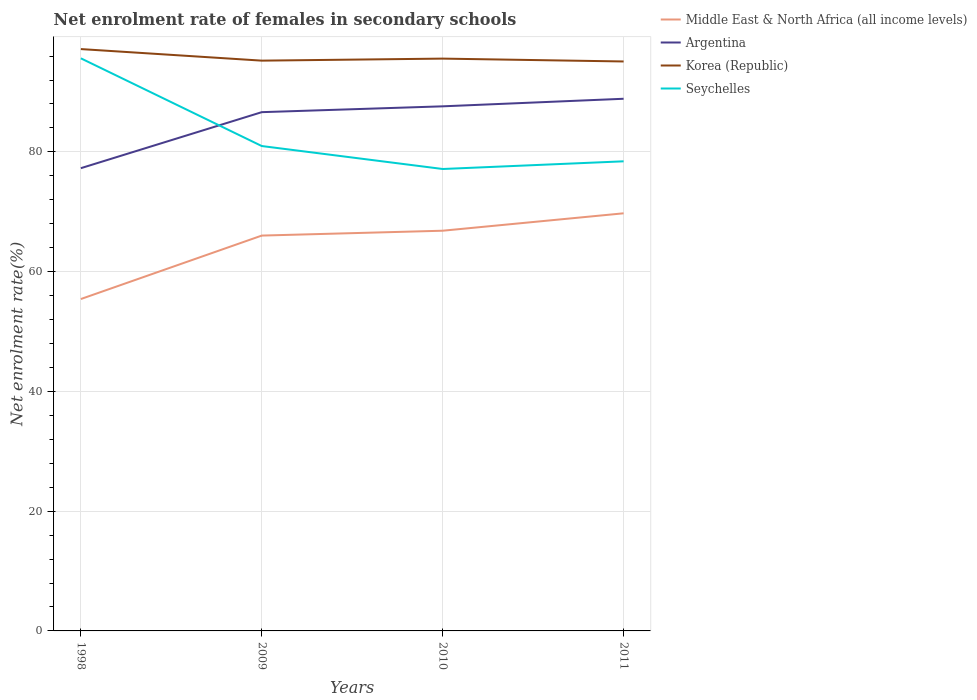Across all years, what is the maximum net enrolment rate of females in secondary schools in Seychelles?
Make the answer very short. 77.14. In which year was the net enrolment rate of females in secondary schools in Korea (Republic) maximum?
Make the answer very short. 2011. What is the total net enrolment rate of females in secondary schools in Korea (Republic) in the graph?
Give a very brief answer. 1.59. What is the difference between the highest and the second highest net enrolment rate of females in secondary schools in Argentina?
Provide a succinct answer. 11.59. What is the difference between the highest and the lowest net enrolment rate of females in secondary schools in Argentina?
Ensure brevity in your answer.  3. What is the difference between two consecutive major ticks on the Y-axis?
Make the answer very short. 20. Are the values on the major ticks of Y-axis written in scientific E-notation?
Keep it short and to the point. No. How are the legend labels stacked?
Your response must be concise. Vertical. What is the title of the graph?
Provide a short and direct response. Net enrolment rate of females in secondary schools. What is the label or title of the X-axis?
Ensure brevity in your answer.  Years. What is the label or title of the Y-axis?
Ensure brevity in your answer.  Net enrolment rate(%). What is the Net enrolment rate(%) in Middle East & North Africa (all income levels) in 1998?
Ensure brevity in your answer.  55.43. What is the Net enrolment rate(%) of Argentina in 1998?
Make the answer very short. 77.28. What is the Net enrolment rate(%) of Korea (Republic) in 1998?
Your response must be concise. 97.17. What is the Net enrolment rate(%) of Seychelles in 1998?
Offer a terse response. 95.63. What is the Net enrolment rate(%) in Middle East & North Africa (all income levels) in 2009?
Ensure brevity in your answer.  66.02. What is the Net enrolment rate(%) of Argentina in 2009?
Provide a short and direct response. 86.64. What is the Net enrolment rate(%) in Korea (Republic) in 2009?
Make the answer very short. 95.24. What is the Net enrolment rate(%) of Seychelles in 2009?
Provide a succinct answer. 80.98. What is the Net enrolment rate(%) in Middle East & North Africa (all income levels) in 2010?
Your response must be concise. 66.84. What is the Net enrolment rate(%) of Argentina in 2010?
Provide a short and direct response. 87.61. What is the Net enrolment rate(%) in Korea (Republic) in 2010?
Your answer should be compact. 95.58. What is the Net enrolment rate(%) in Seychelles in 2010?
Provide a succinct answer. 77.14. What is the Net enrolment rate(%) in Middle East & North Africa (all income levels) in 2011?
Your answer should be compact. 69.74. What is the Net enrolment rate(%) of Argentina in 2011?
Keep it short and to the point. 88.87. What is the Net enrolment rate(%) in Korea (Republic) in 2011?
Your answer should be compact. 95.1. What is the Net enrolment rate(%) of Seychelles in 2011?
Your response must be concise. 78.43. Across all years, what is the maximum Net enrolment rate(%) of Middle East & North Africa (all income levels)?
Your response must be concise. 69.74. Across all years, what is the maximum Net enrolment rate(%) in Argentina?
Provide a short and direct response. 88.87. Across all years, what is the maximum Net enrolment rate(%) in Korea (Republic)?
Your answer should be very brief. 97.17. Across all years, what is the maximum Net enrolment rate(%) in Seychelles?
Ensure brevity in your answer.  95.63. Across all years, what is the minimum Net enrolment rate(%) in Middle East & North Africa (all income levels)?
Keep it short and to the point. 55.43. Across all years, what is the minimum Net enrolment rate(%) in Argentina?
Offer a very short reply. 77.28. Across all years, what is the minimum Net enrolment rate(%) in Korea (Republic)?
Keep it short and to the point. 95.1. Across all years, what is the minimum Net enrolment rate(%) of Seychelles?
Offer a terse response. 77.14. What is the total Net enrolment rate(%) in Middle East & North Africa (all income levels) in the graph?
Offer a terse response. 258.03. What is the total Net enrolment rate(%) of Argentina in the graph?
Give a very brief answer. 340.4. What is the total Net enrolment rate(%) in Korea (Republic) in the graph?
Keep it short and to the point. 383.09. What is the total Net enrolment rate(%) in Seychelles in the graph?
Your answer should be compact. 332.18. What is the difference between the Net enrolment rate(%) of Middle East & North Africa (all income levels) in 1998 and that in 2009?
Offer a very short reply. -10.6. What is the difference between the Net enrolment rate(%) in Argentina in 1998 and that in 2009?
Ensure brevity in your answer.  -9.36. What is the difference between the Net enrolment rate(%) in Korea (Republic) in 1998 and that in 2009?
Give a very brief answer. 1.93. What is the difference between the Net enrolment rate(%) in Seychelles in 1998 and that in 2009?
Make the answer very short. 14.65. What is the difference between the Net enrolment rate(%) in Middle East & North Africa (all income levels) in 1998 and that in 2010?
Make the answer very short. -11.41. What is the difference between the Net enrolment rate(%) of Argentina in 1998 and that in 2010?
Your response must be concise. -10.33. What is the difference between the Net enrolment rate(%) of Korea (Republic) in 1998 and that in 2010?
Provide a short and direct response. 1.59. What is the difference between the Net enrolment rate(%) of Seychelles in 1998 and that in 2010?
Provide a short and direct response. 18.48. What is the difference between the Net enrolment rate(%) of Middle East & North Africa (all income levels) in 1998 and that in 2011?
Keep it short and to the point. -14.32. What is the difference between the Net enrolment rate(%) of Argentina in 1998 and that in 2011?
Give a very brief answer. -11.59. What is the difference between the Net enrolment rate(%) of Korea (Republic) in 1998 and that in 2011?
Ensure brevity in your answer.  2.07. What is the difference between the Net enrolment rate(%) of Seychelles in 1998 and that in 2011?
Give a very brief answer. 17.2. What is the difference between the Net enrolment rate(%) of Middle East & North Africa (all income levels) in 2009 and that in 2010?
Ensure brevity in your answer.  -0.81. What is the difference between the Net enrolment rate(%) in Argentina in 2009 and that in 2010?
Ensure brevity in your answer.  -0.97. What is the difference between the Net enrolment rate(%) of Korea (Republic) in 2009 and that in 2010?
Provide a succinct answer. -0.34. What is the difference between the Net enrolment rate(%) of Seychelles in 2009 and that in 2010?
Make the answer very short. 3.83. What is the difference between the Net enrolment rate(%) in Middle East & North Africa (all income levels) in 2009 and that in 2011?
Your answer should be very brief. -3.72. What is the difference between the Net enrolment rate(%) in Argentina in 2009 and that in 2011?
Make the answer very short. -2.24. What is the difference between the Net enrolment rate(%) of Korea (Republic) in 2009 and that in 2011?
Give a very brief answer. 0.14. What is the difference between the Net enrolment rate(%) in Seychelles in 2009 and that in 2011?
Provide a succinct answer. 2.55. What is the difference between the Net enrolment rate(%) in Middle East & North Africa (all income levels) in 2010 and that in 2011?
Your response must be concise. -2.91. What is the difference between the Net enrolment rate(%) of Argentina in 2010 and that in 2011?
Your response must be concise. -1.26. What is the difference between the Net enrolment rate(%) in Korea (Republic) in 2010 and that in 2011?
Ensure brevity in your answer.  0.48. What is the difference between the Net enrolment rate(%) in Seychelles in 2010 and that in 2011?
Your response must be concise. -1.28. What is the difference between the Net enrolment rate(%) in Middle East & North Africa (all income levels) in 1998 and the Net enrolment rate(%) in Argentina in 2009?
Provide a succinct answer. -31.21. What is the difference between the Net enrolment rate(%) in Middle East & North Africa (all income levels) in 1998 and the Net enrolment rate(%) in Korea (Republic) in 2009?
Your answer should be very brief. -39.81. What is the difference between the Net enrolment rate(%) in Middle East & North Africa (all income levels) in 1998 and the Net enrolment rate(%) in Seychelles in 2009?
Your answer should be compact. -25.55. What is the difference between the Net enrolment rate(%) in Argentina in 1998 and the Net enrolment rate(%) in Korea (Republic) in 2009?
Offer a very short reply. -17.96. What is the difference between the Net enrolment rate(%) in Argentina in 1998 and the Net enrolment rate(%) in Seychelles in 2009?
Ensure brevity in your answer.  -3.7. What is the difference between the Net enrolment rate(%) in Korea (Republic) in 1998 and the Net enrolment rate(%) in Seychelles in 2009?
Your answer should be compact. 16.19. What is the difference between the Net enrolment rate(%) in Middle East & North Africa (all income levels) in 1998 and the Net enrolment rate(%) in Argentina in 2010?
Offer a terse response. -32.18. What is the difference between the Net enrolment rate(%) of Middle East & North Africa (all income levels) in 1998 and the Net enrolment rate(%) of Korea (Republic) in 2010?
Your response must be concise. -40.15. What is the difference between the Net enrolment rate(%) of Middle East & North Africa (all income levels) in 1998 and the Net enrolment rate(%) of Seychelles in 2010?
Offer a terse response. -21.72. What is the difference between the Net enrolment rate(%) in Argentina in 1998 and the Net enrolment rate(%) in Korea (Republic) in 2010?
Offer a very short reply. -18.3. What is the difference between the Net enrolment rate(%) in Argentina in 1998 and the Net enrolment rate(%) in Seychelles in 2010?
Offer a terse response. 0.14. What is the difference between the Net enrolment rate(%) of Korea (Republic) in 1998 and the Net enrolment rate(%) of Seychelles in 2010?
Keep it short and to the point. 20.03. What is the difference between the Net enrolment rate(%) in Middle East & North Africa (all income levels) in 1998 and the Net enrolment rate(%) in Argentina in 2011?
Your response must be concise. -33.45. What is the difference between the Net enrolment rate(%) of Middle East & North Africa (all income levels) in 1998 and the Net enrolment rate(%) of Korea (Republic) in 2011?
Your answer should be very brief. -39.67. What is the difference between the Net enrolment rate(%) in Middle East & North Africa (all income levels) in 1998 and the Net enrolment rate(%) in Seychelles in 2011?
Keep it short and to the point. -23. What is the difference between the Net enrolment rate(%) in Argentina in 1998 and the Net enrolment rate(%) in Korea (Republic) in 2011?
Ensure brevity in your answer.  -17.82. What is the difference between the Net enrolment rate(%) in Argentina in 1998 and the Net enrolment rate(%) in Seychelles in 2011?
Offer a terse response. -1.15. What is the difference between the Net enrolment rate(%) in Korea (Republic) in 1998 and the Net enrolment rate(%) in Seychelles in 2011?
Make the answer very short. 18.75. What is the difference between the Net enrolment rate(%) of Middle East & North Africa (all income levels) in 2009 and the Net enrolment rate(%) of Argentina in 2010?
Your answer should be compact. -21.58. What is the difference between the Net enrolment rate(%) of Middle East & North Africa (all income levels) in 2009 and the Net enrolment rate(%) of Korea (Republic) in 2010?
Offer a terse response. -29.55. What is the difference between the Net enrolment rate(%) of Middle East & North Africa (all income levels) in 2009 and the Net enrolment rate(%) of Seychelles in 2010?
Keep it short and to the point. -11.12. What is the difference between the Net enrolment rate(%) in Argentina in 2009 and the Net enrolment rate(%) in Korea (Republic) in 2010?
Your answer should be very brief. -8.94. What is the difference between the Net enrolment rate(%) of Argentina in 2009 and the Net enrolment rate(%) of Seychelles in 2010?
Your response must be concise. 9.49. What is the difference between the Net enrolment rate(%) of Korea (Republic) in 2009 and the Net enrolment rate(%) of Seychelles in 2010?
Your answer should be compact. 18.1. What is the difference between the Net enrolment rate(%) of Middle East & North Africa (all income levels) in 2009 and the Net enrolment rate(%) of Argentina in 2011?
Your answer should be compact. -22.85. What is the difference between the Net enrolment rate(%) in Middle East & North Africa (all income levels) in 2009 and the Net enrolment rate(%) in Korea (Republic) in 2011?
Offer a very short reply. -29.08. What is the difference between the Net enrolment rate(%) in Middle East & North Africa (all income levels) in 2009 and the Net enrolment rate(%) in Seychelles in 2011?
Offer a terse response. -12.4. What is the difference between the Net enrolment rate(%) in Argentina in 2009 and the Net enrolment rate(%) in Korea (Republic) in 2011?
Offer a terse response. -8.47. What is the difference between the Net enrolment rate(%) in Argentina in 2009 and the Net enrolment rate(%) in Seychelles in 2011?
Your answer should be very brief. 8.21. What is the difference between the Net enrolment rate(%) in Korea (Republic) in 2009 and the Net enrolment rate(%) in Seychelles in 2011?
Your answer should be compact. 16.81. What is the difference between the Net enrolment rate(%) of Middle East & North Africa (all income levels) in 2010 and the Net enrolment rate(%) of Argentina in 2011?
Your response must be concise. -22.04. What is the difference between the Net enrolment rate(%) in Middle East & North Africa (all income levels) in 2010 and the Net enrolment rate(%) in Korea (Republic) in 2011?
Offer a terse response. -28.27. What is the difference between the Net enrolment rate(%) in Middle East & North Africa (all income levels) in 2010 and the Net enrolment rate(%) in Seychelles in 2011?
Your answer should be compact. -11.59. What is the difference between the Net enrolment rate(%) in Argentina in 2010 and the Net enrolment rate(%) in Korea (Republic) in 2011?
Ensure brevity in your answer.  -7.49. What is the difference between the Net enrolment rate(%) in Argentina in 2010 and the Net enrolment rate(%) in Seychelles in 2011?
Provide a short and direct response. 9.18. What is the difference between the Net enrolment rate(%) in Korea (Republic) in 2010 and the Net enrolment rate(%) in Seychelles in 2011?
Your response must be concise. 17.15. What is the average Net enrolment rate(%) in Middle East & North Africa (all income levels) per year?
Offer a terse response. 64.51. What is the average Net enrolment rate(%) in Argentina per year?
Keep it short and to the point. 85.1. What is the average Net enrolment rate(%) in Korea (Republic) per year?
Give a very brief answer. 95.77. What is the average Net enrolment rate(%) in Seychelles per year?
Give a very brief answer. 83.04. In the year 1998, what is the difference between the Net enrolment rate(%) in Middle East & North Africa (all income levels) and Net enrolment rate(%) in Argentina?
Make the answer very short. -21.85. In the year 1998, what is the difference between the Net enrolment rate(%) in Middle East & North Africa (all income levels) and Net enrolment rate(%) in Korea (Republic)?
Your answer should be very brief. -41.74. In the year 1998, what is the difference between the Net enrolment rate(%) in Middle East & North Africa (all income levels) and Net enrolment rate(%) in Seychelles?
Ensure brevity in your answer.  -40.2. In the year 1998, what is the difference between the Net enrolment rate(%) of Argentina and Net enrolment rate(%) of Korea (Republic)?
Provide a short and direct response. -19.89. In the year 1998, what is the difference between the Net enrolment rate(%) of Argentina and Net enrolment rate(%) of Seychelles?
Keep it short and to the point. -18.35. In the year 1998, what is the difference between the Net enrolment rate(%) in Korea (Republic) and Net enrolment rate(%) in Seychelles?
Your answer should be compact. 1.55. In the year 2009, what is the difference between the Net enrolment rate(%) of Middle East & North Africa (all income levels) and Net enrolment rate(%) of Argentina?
Offer a very short reply. -20.61. In the year 2009, what is the difference between the Net enrolment rate(%) of Middle East & North Africa (all income levels) and Net enrolment rate(%) of Korea (Republic)?
Your response must be concise. -29.22. In the year 2009, what is the difference between the Net enrolment rate(%) in Middle East & North Africa (all income levels) and Net enrolment rate(%) in Seychelles?
Provide a short and direct response. -14.95. In the year 2009, what is the difference between the Net enrolment rate(%) of Argentina and Net enrolment rate(%) of Korea (Republic)?
Give a very brief answer. -8.6. In the year 2009, what is the difference between the Net enrolment rate(%) of Argentina and Net enrolment rate(%) of Seychelles?
Offer a terse response. 5.66. In the year 2009, what is the difference between the Net enrolment rate(%) in Korea (Republic) and Net enrolment rate(%) in Seychelles?
Ensure brevity in your answer.  14.26. In the year 2010, what is the difference between the Net enrolment rate(%) in Middle East & North Africa (all income levels) and Net enrolment rate(%) in Argentina?
Your response must be concise. -20.77. In the year 2010, what is the difference between the Net enrolment rate(%) of Middle East & North Africa (all income levels) and Net enrolment rate(%) of Korea (Republic)?
Provide a succinct answer. -28.74. In the year 2010, what is the difference between the Net enrolment rate(%) of Middle East & North Africa (all income levels) and Net enrolment rate(%) of Seychelles?
Your answer should be very brief. -10.31. In the year 2010, what is the difference between the Net enrolment rate(%) in Argentina and Net enrolment rate(%) in Korea (Republic)?
Your answer should be very brief. -7.97. In the year 2010, what is the difference between the Net enrolment rate(%) in Argentina and Net enrolment rate(%) in Seychelles?
Provide a short and direct response. 10.46. In the year 2010, what is the difference between the Net enrolment rate(%) in Korea (Republic) and Net enrolment rate(%) in Seychelles?
Your answer should be compact. 18.43. In the year 2011, what is the difference between the Net enrolment rate(%) of Middle East & North Africa (all income levels) and Net enrolment rate(%) of Argentina?
Provide a succinct answer. -19.13. In the year 2011, what is the difference between the Net enrolment rate(%) in Middle East & North Africa (all income levels) and Net enrolment rate(%) in Korea (Republic)?
Your answer should be compact. -25.36. In the year 2011, what is the difference between the Net enrolment rate(%) in Middle East & North Africa (all income levels) and Net enrolment rate(%) in Seychelles?
Provide a succinct answer. -8.68. In the year 2011, what is the difference between the Net enrolment rate(%) of Argentina and Net enrolment rate(%) of Korea (Republic)?
Your response must be concise. -6.23. In the year 2011, what is the difference between the Net enrolment rate(%) in Argentina and Net enrolment rate(%) in Seychelles?
Offer a very short reply. 10.45. In the year 2011, what is the difference between the Net enrolment rate(%) of Korea (Republic) and Net enrolment rate(%) of Seychelles?
Provide a succinct answer. 16.68. What is the ratio of the Net enrolment rate(%) of Middle East & North Africa (all income levels) in 1998 to that in 2009?
Offer a very short reply. 0.84. What is the ratio of the Net enrolment rate(%) of Argentina in 1998 to that in 2009?
Your response must be concise. 0.89. What is the ratio of the Net enrolment rate(%) in Korea (Republic) in 1998 to that in 2009?
Offer a very short reply. 1.02. What is the ratio of the Net enrolment rate(%) of Seychelles in 1998 to that in 2009?
Offer a very short reply. 1.18. What is the ratio of the Net enrolment rate(%) of Middle East & North Africa (all income levels) in 1998 to that in 2010?
Offer a very short reply. 0.83. What is the ratio of the Net enrolment rate(%) of Argentina in 1998 to that in 2010?
Offer a very short reply. 0.88. What is the ratio of the Net enrolment rate(%) in Korea (Republic) in 1998 to that in 2010?
Keep it short and to the point. 1.02. What is the ratio of the Net enrolment rate(%) in Seychelles in 1998 to that in 2010?
Keep it short and to the point. 1.24. What is the ratio of the Net enrolment rate(%) of Middle East & North Africa (all income levels) in 1998 to that in 2011?
Keep it short and to the point. 0.79. What is the ratio of the Net enrolment rate(%) of Argentina in 1998 to that in 2011?
Make the answer very short. 0.87. What is the ratio of the Net enrolment rate(%) in Korea (Republic) in 1998 to that in 2011?
Your answer should be compact. 1.02. What is the ratio of the Net enrolment rate(%) in Seychelles in 1998 to that in 2011?
Provide a short and direct response. 1.22. What is the ratio of the Net enrolment rate(%) of Middle East & North Africa (all income levels) in 2009 to that in 2010?
Your answer should be compact. 0.99. What is the ratio of the Net enrolment rate(%) of Argentina in 2009 to that in 2010?
Your response must be concise. 0.99. What is the ratio of the Net enrolment rate(%) of Korea (Republic) in 2009 to that in 2010?
Keep it short and to the point. 1. What is the ratio of the Net enrolment rate(%) of Seychelles in 2009 to that in 2010?
Your answer should be compact. 1.05. What is the ratio of the Net enrolment rate(%) of Middle East & North Africa (all income levels) in 2009 to that in 2011?
Offer a terse response. 0.95. What is the ratio of the Net enrolment rate(%) of Argentina in 2009 to that in 2011?
Make the answer very short. 0.97. What is the ratio of the Net enrolment rate(%) of Korea (Republic) in 2009 to that in 2011?
Your answer should be very brief. 1. What is the ratio of the Net enrolment rate(%) of Seychelles in 2009 to that in 2011?
Your response must be concise. 1.03. What is the ratio of the Net enrolment rate(%) in Middle East & North Africa (all income levels) in 2010 to that in 2011?
Keep it short and to the point. 0.96. What is the ratio of the Net enrolment rate(%) in Argentina in 2010 to that in 2011?
Your response must be concise. 0.99. What is the ratio of the Net enrolment rate(%) of Seychelles in 2010 to that in 2011?
Make the answer very short. 0.98. What is the difference between the highest and the second highest Net enrolment rate(%) of Middle East & North Africa (all income levels)?
Make the answer very short. 2.91. What is the difference between the highest and the second highest Net enrolment rate(%) in Argentina?
Give a very brief answer. 1.26. What is the difference between the highest and the second highest Net enrolment rate(%) of Korea (Republic)?
Your answer should be very brief. 1.59. What is the difference between the highest and the second highest Net enrolment rate(%) of Seychelles?
Your answer should be very brief. 14.65. What is the difference between the highest and the lowest Net enrolment rate(%) in Middle East & North Africa (all income levels)?
Make the answer very short. 14.32. What is the difference between the highest and the lowest Net enrolment rate(%) of Argentina?
Offer a very short reply. 11.59. What is the difference between the highest and the lowest Net enrolment rate(%) in Korea (Republic)?
Your answer should be very brief. 2.07. What is the difference between the highest and the lowest Net enrolment rate(%) of Seychelles?
Offer a terse response. 18.48. 